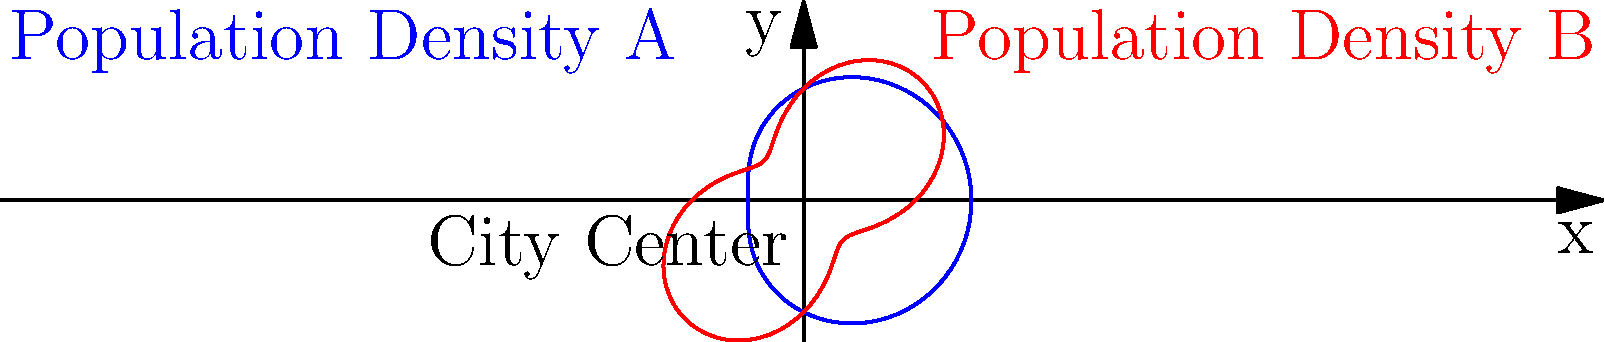A circular city has two distinct population density distributions represented by polar equations. Distribution A is given by $r = 2 + \cos(\theta)$, and Distribution B is given by $r = 2 + \sin(2\theta)$, where $r$ is the distance from the city center in kilometers and $\theta$ is the angle in radians. At what angle $\theta$ (in radians) do these two distributions intersect for the first time in the first quadrant? To find the intersection point, we need to equate the two equations and solve for $\theta$:

1) Set the equations equal to each other:
   $2 + \cos(\theta) = 2 + \sin(2\theta)$

2) Simplify:
   $\cos(\theta) = \sin(2\theta)$

3) Use the double angle formula for sine:
   $\cos(\theta) = 2\sin(\theta)\cos(\theta)$

4) Divide both sides by $\cos(\theta)$ (assuming $\cos(\theta) \neq 0$):
   $1 = 2\sin(\theta)$

5) Solve for $\theta$:
   $\sin(\theta) = \frac{1}{2}$

6) In the first quadrant, this corresponds to:
   $\theta = \arcsin(\frac{1}{2}) = \frac{\pi}{6}$

7) Verify that this solution satisfies the original equations:
   For $r = 2 + \cos(\frac{\pi}{6}) = 2 + \frac{\sqrt{3}}{2} \approx 3.866$
   For $r = 2 + \sin(2\cdot\frac{\pi}{6}) = 2 + \sin(\frac{\pi}{3}) = 2 + \frac{\sqrt{3}}{2} \approx 3.866$

Therefore, the two distributions intersect at $\theta = \frac{\pi}{6}$ radians in the first quadrant.
Answer: $\frac{\pi}{6}$ radians 